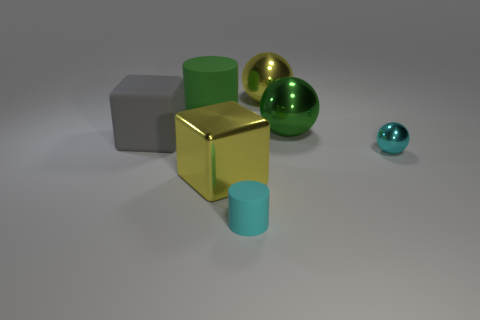Is the number of small rubber objects that are on the right side of the cyan sphere the same as the number of green metallic balls that are to the left of the yellow ball?
Provide a succinct answer. Yes. How many other objects are the same shape as the cyan shiny thing?
Offer a terse response. 2. Is there a large green thing made of the same material as the cyan ball?
Your response must be concise. Yes. There is a matte thing that is the same color as the small ball; what shape is it?
Your answer should be compact. Cylinder. What number of tiny brown cylinders are there?
Provide a short and direct response. 0. How many cylinders are either small cyan shiny things or metal things?
Your response must be concise. 0. What color is the metal cube that is the same size as the yellow ball?
Offer a terse response. Yellow. What number of things are right of the big yellow cube and in front of the small ball?
Offer a very short reply. 1. What is the material of the large yellow ball?
Provide a short and direct response. Metal. What number of things are either cyan shiny objects or big blue cylinders?
Give a very brief answer. 1. 